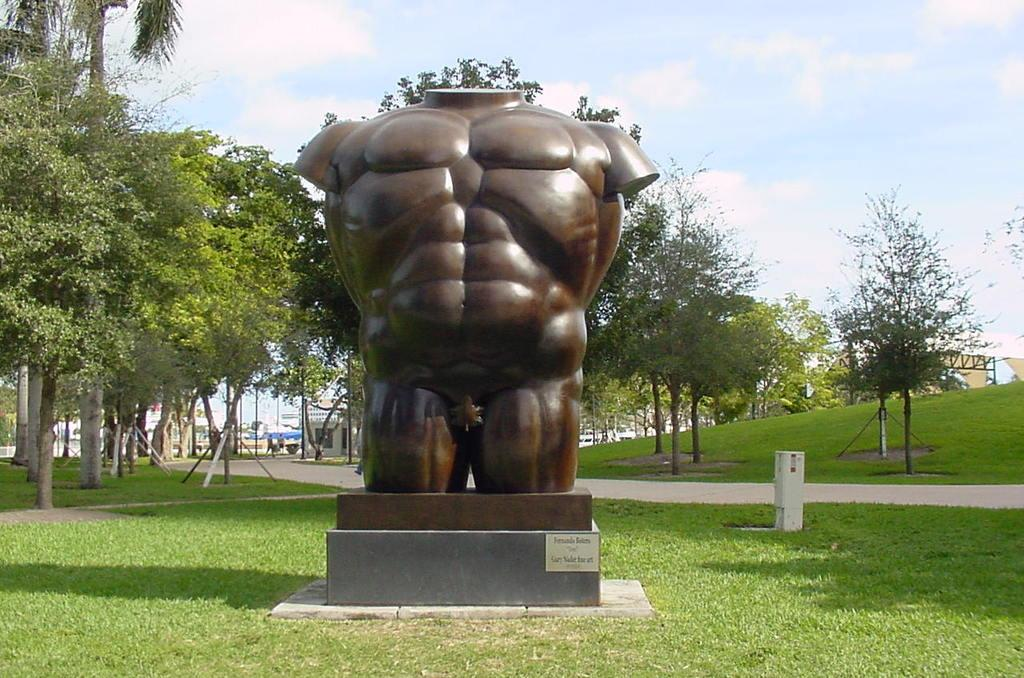What is the main subject in the image? There is a statue in the image. Where is the statue located? The statue is on the surface of the grass. What can be seen in the background of the image? There are trees, buildings, and the sky visible in the background of the image. What is the aftermath of the competition in the image? There is no competition or aftermath present in the image; it features a statue on the grass with trees, buildings, and the sky in the background. 